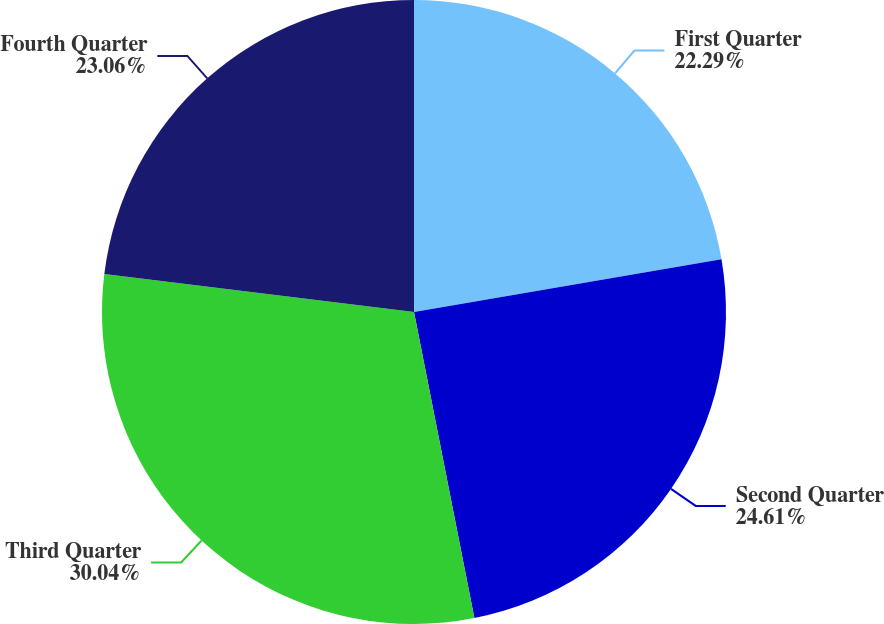Convert chart. <chart><loc_0><loc_0><loc_500><loc_500><pie_chart><fcel>First Quarter<fcel>Second Quarter<fcel>Third Quarter<fcel>Fourth Quarter<nl><fcel>22.29%<fcel>24.61%<fcel>30.04%<fcel>23.06%<nl></chart> 